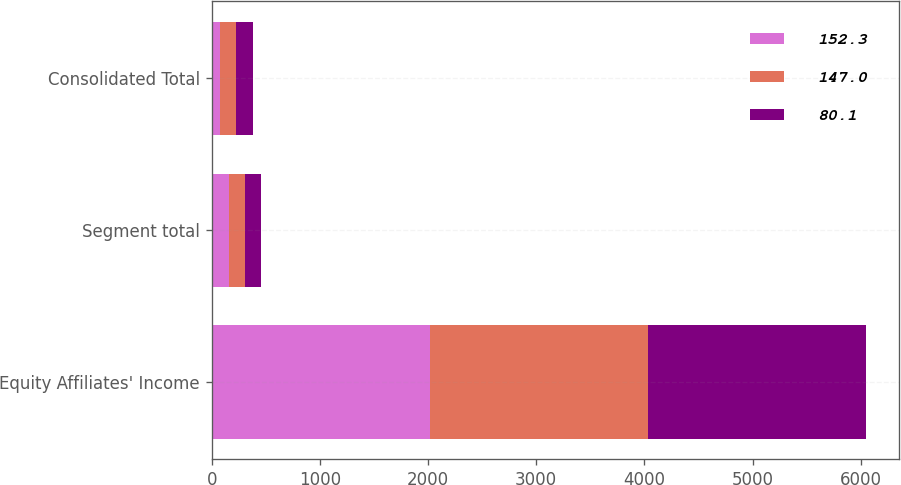Convert chart to OTSL. <chart><loc_0><loc_0><loc_500><loc_500><stacked_bar_chart><ecel><fcel>Equity Affiliates' Income<fcel>Segment total<fcel>Consolidated Total<nl><fcel>152.3<fcel>2017<fcel>159.6<fcel>80.1<nl><fcel>147<fcel>2016<fcel>147<fcel>147<nl><fcel>80.1<fcel>2015<fcel>152.3<fcel>152.3<nl></chart> 